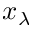Convert formula to latex. <formula><loc_0><loc_0><loc_500><loc_500>x _ { \lambda }</formula> 